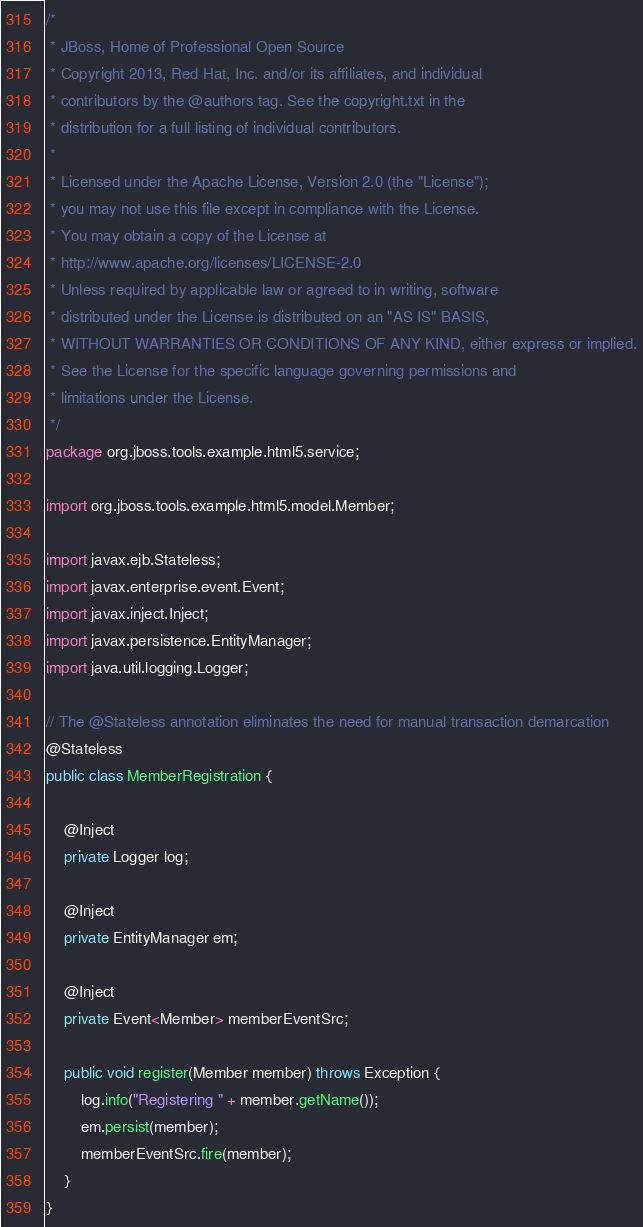<code> <loc_0><loc_0><loc_500><loc_500><_Java_>/*
 * JBoss, Home of Professional Open Source
 * Copyright 2013, Red Hat, Inc. and/or its affiliates, and individual
 * contributors by the @authors tag. See the copyright.txt in the
 * distribution for a full listing of individual contributors.
 *
 * Licensed under the Apache License, Version 2.0 (the "License");
 * you may not use this file except in compliance with the License.
 * You may obtain a copy of the License at
 * http://www.apache.org/licenses/LICENSE-2.0
 * Unless required by applicable law or agreed to in writing, software
 * distributed under the License is distributed on an "AS IS" BASIS,
 * WITHOUT WARRANTIES OR CONDITIONS OF ANY KIND, either express or implied.
 * See the License for the specific language governing permissions and
 * limitations under the License.
 */
package org.jboss.tools.example.html5.service;

import org.jboss.tools.example.html5.model.Member;

import javax.ejb.Stateless;
import javax.enterprise.event.Event;
import javax.inject.Inject;
import javax.persistence.EntityManager;
import java.util.logging.Logger;

// The @Stateless annotation eliminates the need for manual transaction demarcation
@Stateless
public class MemberRegistration {

    @Inject
    private Logger log;

    @Inject
    private EntityManager em;

    @Inject
    private Event<Member> memberEventSrc;

    public void register(Member member) throws Exception {
        log.info("Registering " + member.getName());
        em.persist(member);
        memberEventSrc.fire(member);
    }
}
</code> 